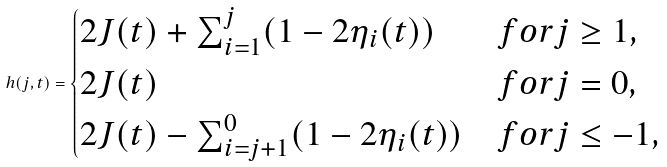Convert formula to latex. <formula><loc_0><loc_0><loc_500><loc_500>h ( j , t ) = \begin{cases} 2 J ( t ) + \sum ^ { j } _ { i = 1 } ( 1 - 2 \eta _ { i } ( t ) ) & f o r j \geq 1 , \\ 2 J ( t ) & f o r j = 0 , \\ 2 J ( t ) - \sum ^ { 0 } _ { i = j + 1 } ( 1 - 2 \eta _ { i } ( t ) ) & f o r j \leq - 1 , \end{cases}</formula> 